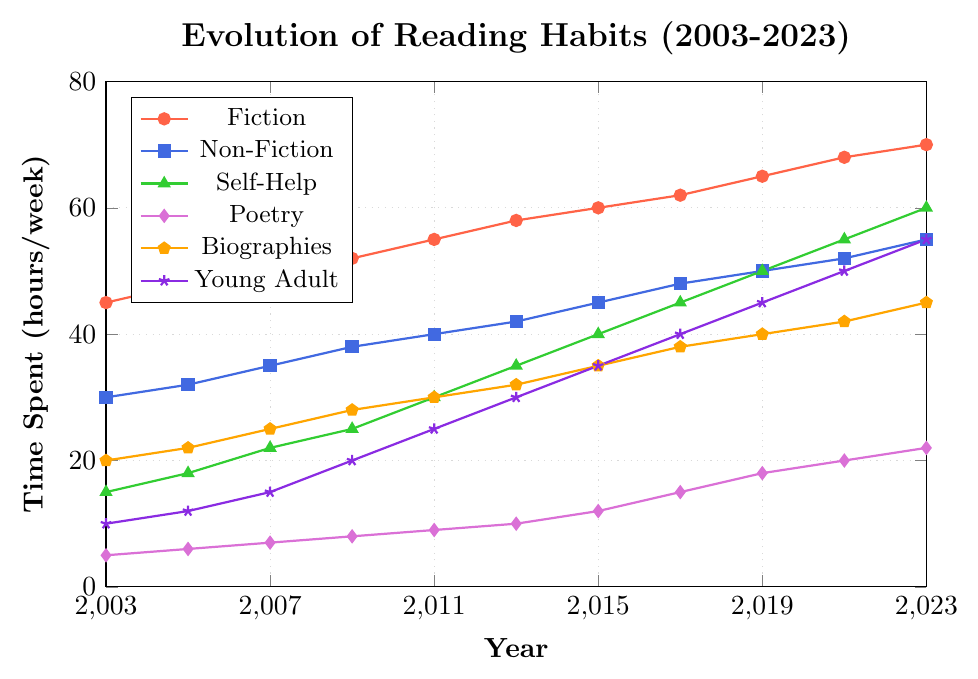What genre has seen the greatest absolute increase in average weekly reading time from 2003 to 2023? To find the genre with the greatest absolute increase, subtract the reading time in 2003 from the reading time in 2023 for each genre. Fiction: 70-45=25, Non-Fiction: 55-30=25, Self-Help: 60-15=45, Poetry: 22-5=17, Biographies: 45-20=25, Young Adult: 55-10=45. The greatest increase is seen in Self-Help and Young Adult, both increasing by 45 hours per week.
Answer: Self-Help, Young Adult By how many hours did the total time spent on all genres increase from 2003 to 2023? First, find the total reading time for all genres in both years. In 2003: 45+30+15+5+20+10 = 125 hours. In 2023: 70+55+60+22+45+55 = 307 hours. Then subtract 125 from 307 to find the increase.
Answer: 182 hours Which genre had the least growth in reading time from 2003 to 2023? Subtract the reading time in 2003 from the reading time in 2023 for each genre: Fiction: 25 hours, Non-Fiction: 25 hours, Self-Help: 45 hours, Poetry: 17 hours, Biographies: 25 hours, Young Adult: 45 hours. The least growth is in Poetry, with 17 hours increase.
Answer: Poetry How did the time spent on Non-Fiction change relative to that spent on Fiction from 2003 to 2023? In 2003, Non-Fiction was 15 hours less than Fiction (45-30=15). In 2023, Non-Fiction was 15 hours less than Fiction (70-55=15). The relative change in their difference did not change over the two decades.
Answer: No change In what year did the time spent on Young Adult exceed that of Poetry by 25 hours for the first time? Identify the specific years' data and calculate the difference: 2009: 20-8=12, 2011: 25-9=16, 2013: 30-10=20, 2015: 35-12=23, 2017: 40-15=25. Therefore, 2017 was the first year Young Adult exceeded Poetry by 25 hours.
Answer: 2017 